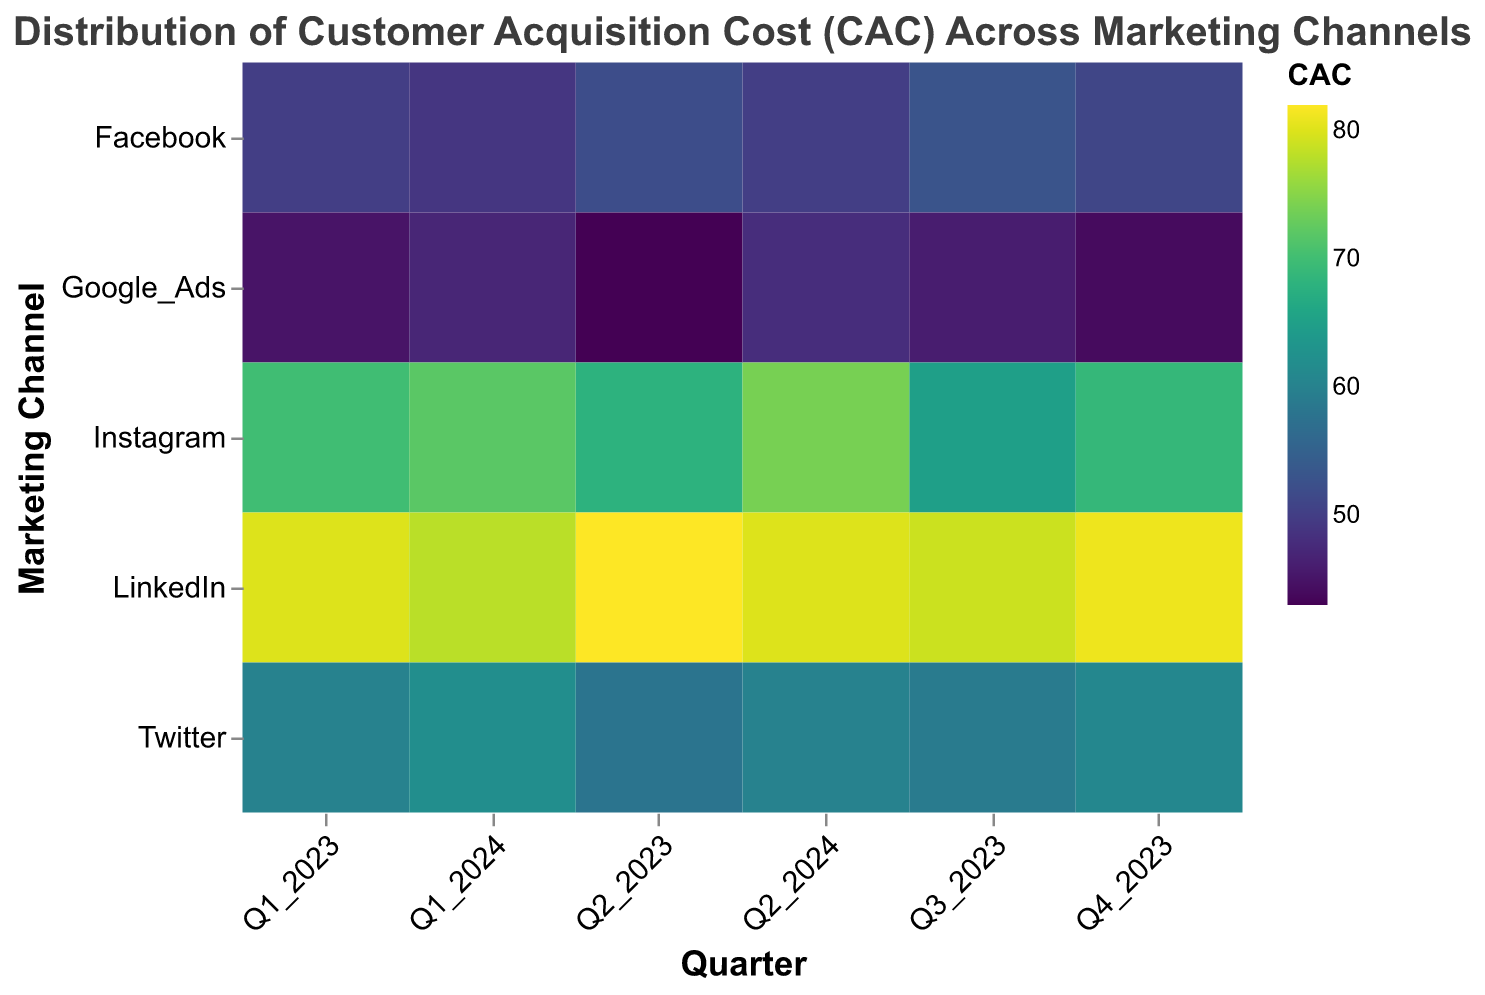What is the title of the figure? The title can be found at the top of the figure, reading it directly provides the information.
Answer: Distribution of Customer Acquisition Cost (CAC) Across Marketing Channels Which quarter has the highest CAC for LinkedIn? Look for the highest color intensity (or numeric value) for the LinkedIn row and check the corresponding quarter.
Answer: Q2_2023 What is the general trend of CAC for Twitter from Q1_2023 to Q2_2024? Follow the colors or numeric values in the Twitter row through the quarters to see if they increase, decrease, or stay the same.
Answer: Increasing Which marketing channel has the lowest CAC in Q3_2023? Look for the lowest value or lightest color tones in Q3_2023 column and identify the corresponding marketing channel.
Answer: Google_Ads Compare the average CAC for Facebook and Instagram across all quarters. Which one is higher? Calculate the average CAC for Facebook and Instagram by adding up the values for each quarter and dividing by the number of quarters (6). Compare the two averages.
Answer: Instagram What are the CAC values for LinkedIn in Q1_2023 and Q1_2024, and what is the difference between them? Identify the CAC values for LinkedIn in Q1_2023 and Q1_2024. Subtract the latter from the former.
Answer: 80 in Q1_2023, 78 in Q1_2024, Difference: 2 Which quarter shows the highest overall CAC values across all marketing channels? Observe the distribution of colors or values in each quarter's column to identify the one with the most intense colors or highest values overall.
Answer: Q2_2024 What is the overall trend of CAC for Google Ads from Q1_2023 to Q2_2024? Track the changes in the values or color intensities for Google Ads across the quarters to determine if they generally increase, decrease, or trend otherwise.
Answer: Increasing Which marketing channel has the most stable CAC across the quarters? Evaluate the variances in color intensity or numeric differences within each row to identify the one with the least fluctuation.
Answer: Google_Ads 